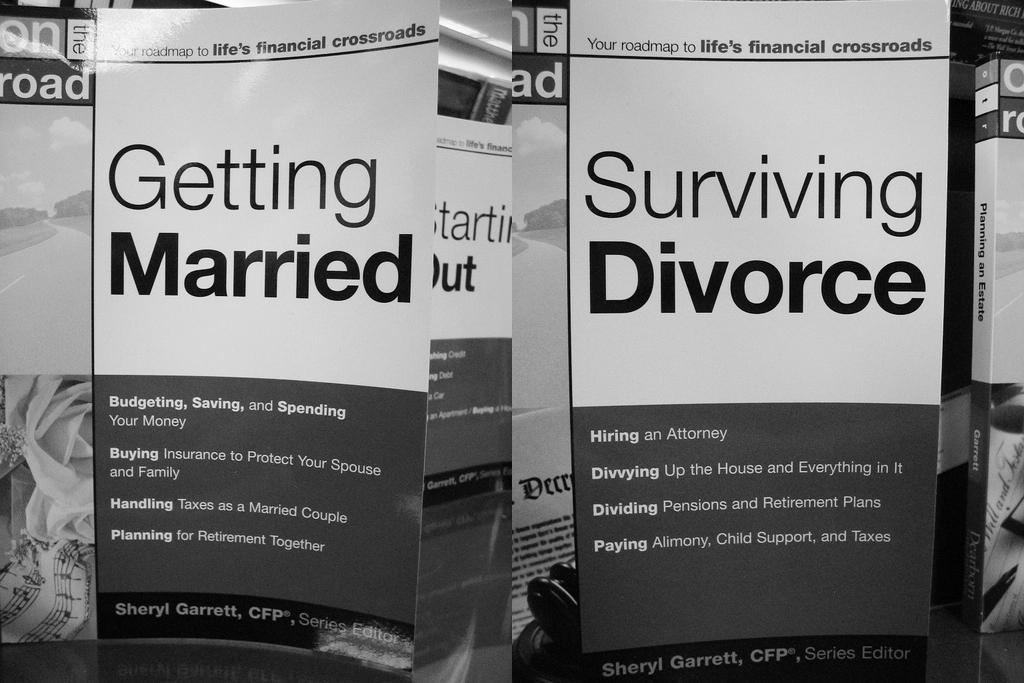<image>
Write a terse but informative summary of the picture. Several books are shown with the two titles, Getting Married and Surviving Divorce, at the forefront. 